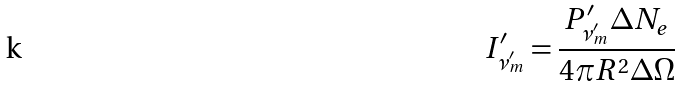Convert formula to latex. <formula><loc_0><loc_0><loc_500><loc_500>I ^ { \prime } _ { \nu ^ { \prime } _ { m } } = \frac { P ^ { \prime } _ { \nu ^ { \prime } _ { m } } \Delta N _ { e } } { 4 \pi R ^ { 2 } \Delta \Omega }</formula> 